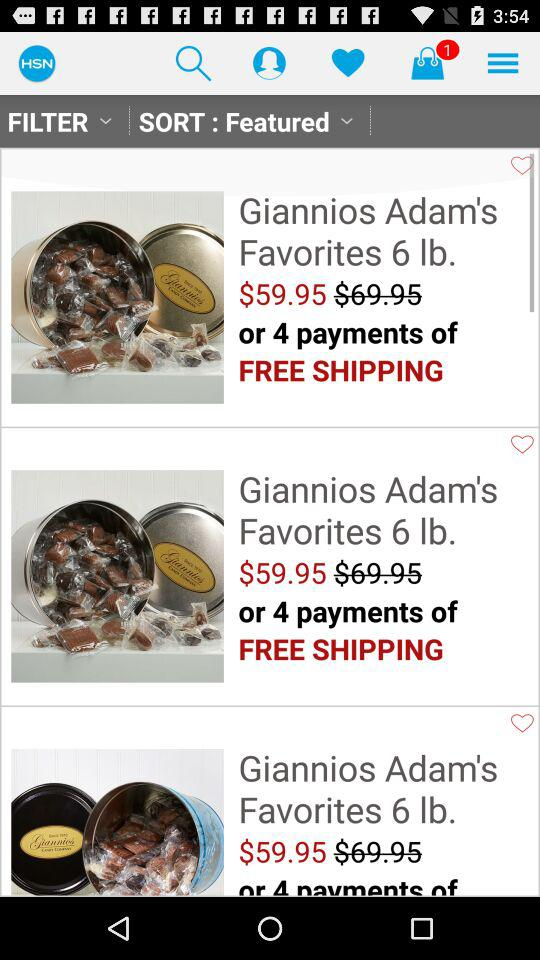What is the name of the application? The name of the application is "HSN". 